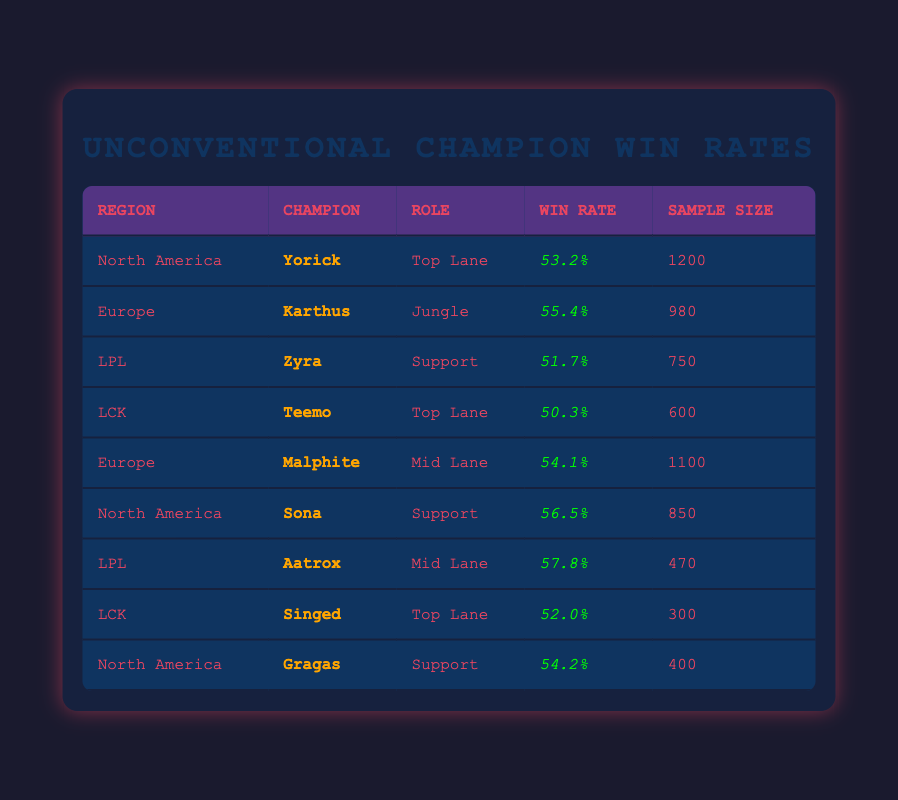What is the win rate of Yorick in North America? The table shows that Yorick has a win rate listed in the row under North America. That value is 53.2%.
Answer: 53.2% Which champion has the highest win rate in this table? By comparing all the win rates listed, Aatrox has the highest win rate at 57.8%.
Answer: Aatrox What role does Karthus play in Europe? The table indicates that Karthus is categorized under the Jungle role in Europe.
Answer: Jungle How many samples were collected for Sona in North America? The table specifically lists the sample size for Sona, which is shown as 850 in the respective row.
Answer: 850 What is the average win rate of the champions listed in the LPL region? To find the average, we sum the win rates of Zyra (51.7%) and Aatrox (57.8%) and divide by 2: (51.7 + 57.8) / 2 = 54.75%.
Answer: 54.75% Is the win rate of Singed higher than 50% in the LCK region? Looking at the table, Singed's win rate is listed as 52.0%, which is indeed higher than 50%.
Answer: Yes Which region features both Gragas and Sona? By reviewing the table, both Gragas and Sona appear in the North America region.
Answer: North America What is the difference in win rates between Malphite and Karthus? Karthus's win rate is 55.4% and Malphite's win rate is 54.1%. The difference is 55.4 - 54.1 = 1.3%.
Answer: 1.3% In how many regions is the champion Teemo played, and what is that region? The table only lists Teemo under the LCK region, meaning he is played in 1 region.
Answer: 1 region (LCK) Which unconventional champion has the lowest win rate in the table? By assessing all the champions, Teemo has the lowest win rate listed at 50.3%.
Answer: Teemo 